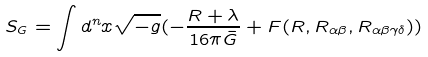<formula> <loc_0><loc_0><loc_500><loc_500>S _ { G } = \int d ^ { n } x \sqrt { - g } ( - \frac { R + \lambda } { 1 6 \pi \bar { G } } + F ( R , R _ { \alpha \beta } , R _ { \alpha \beta \gamma \delta } ) )</formula> 